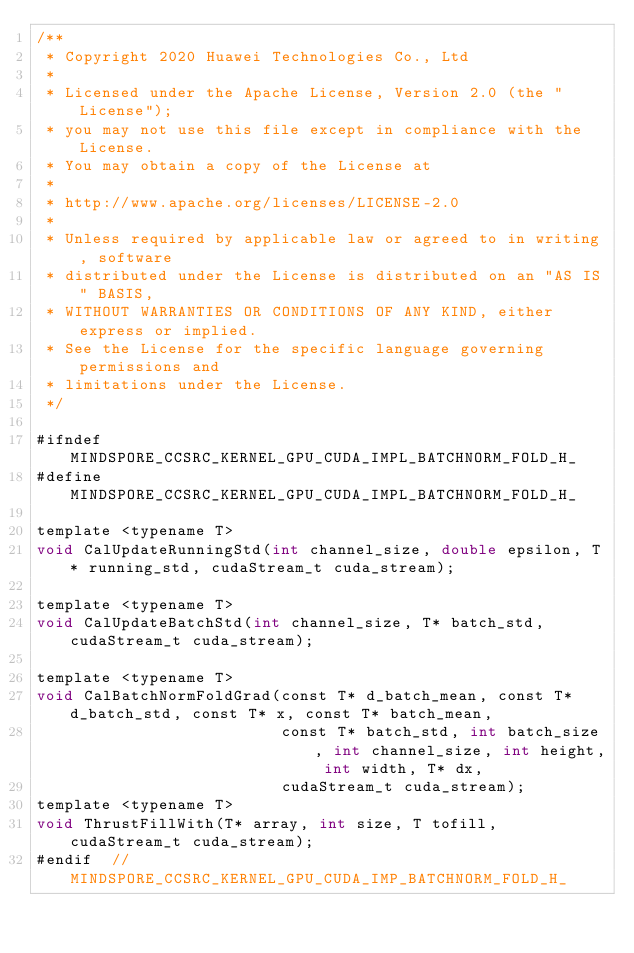Convert code to text. <code><loc_0><loc_0><loc_500><loc_500><_Cuda_>/**
 * Copyright 2020 Huawei Technologies Co., Ltd
 *
 * Licensed under the Apache License, Version 2.0 (the "License");
 * you may not use this file except in compliance with the License.
 * You may obtain a copy of the License at
 *
 * http://www.apache.org/licenses/LICENSE-2.0
 *
 * Unless required by applicable law or agreed to in writing, software
 * distributed under the License is distributed on an "AS IS" BASIS,
 * WITHOUT WARRANTIES OR CONDITIONS OF ANY KIND, either express or implied.
 * See the License for the specific language governing permissions and
 * limitations under the License.
 */

#ifndef MINDSPORE_CCSRC_KERNEL_GPU_CUDA_IMPL_BATCHNORM_FOLD_H_
#define MINDSPORE_CCSRC_KERNEL_GPU_CUDA_IMPL_BATCHNORM_FOLD_H_

template <typename T>
void CalUpdateRunningStd(int channel_size, double epsilon, T* running_std, cudaStream_t cuda_stream);

template <typename T>
void CalUpdateBatchStd(int channel_size, T* batch_std, cudaStream_t cuda_stream);

template <typename T>
void CalBatchNormFoldGrad(const T* d_batch_mean, const T* d_batch_std, const T* x, const T* batch_mean,
                          const T* batch_std, int batch_size, int channel_size, int height, int width, T* dx,
                          cudaStream_t cuda_stream);
template <typename T>
void ThrustFillWith(T* array, int size, T tofill, cudaStream_t cuda_stream);
#endif  // MINDSPORE_CCSRC_KERNEL_GPU_CUDA_IMP_BATCHNORM_FOLD_H_
</code> 